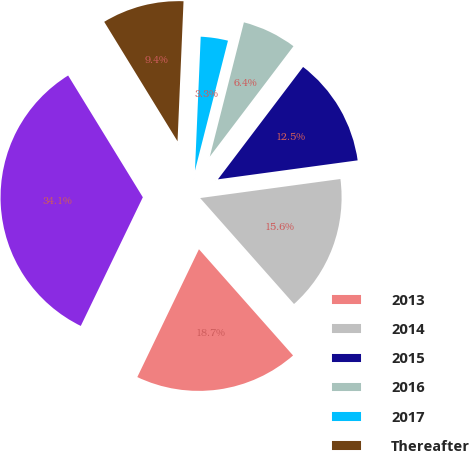Convert chart to OTSL. <chart><loc_0><loc_0><loc_500><loc_500><pie_chart><fcel>2013<fcel>2014<fcel>2015<fcel>2016<fcel>2017<fcel>Thereafter<fcel>Total<nl><fcel>18.69%<fcel>15.61%<fcel>12.53%<fcel>6.36%<fcel>3.28%<fcel>9.44%<fcel>34.09%<nl></chart> 